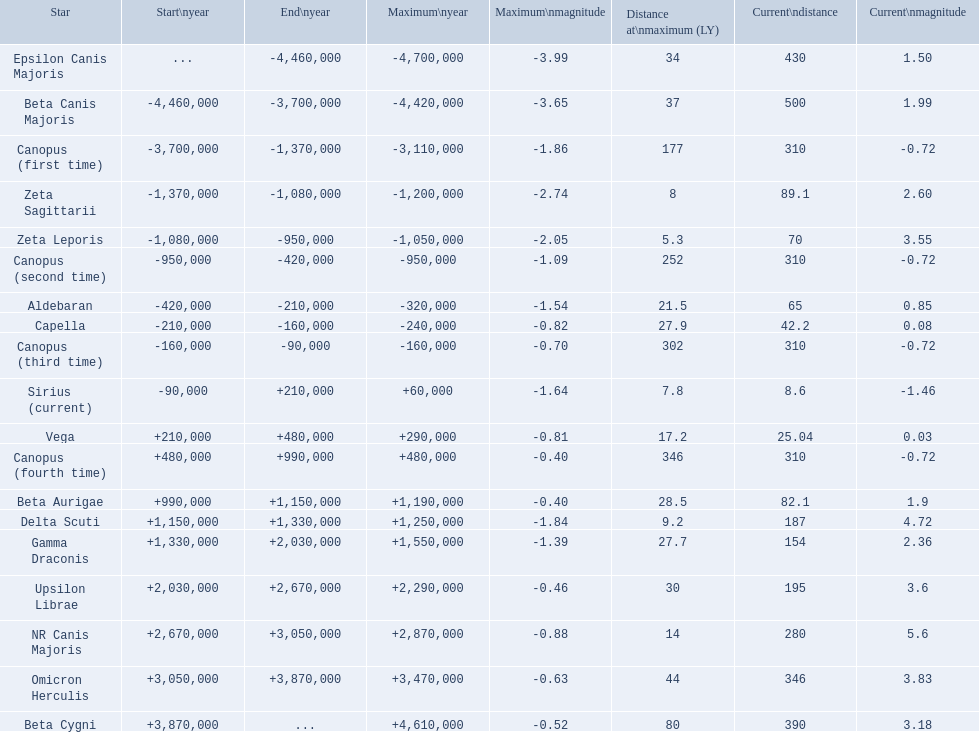What are all the stars? Epsilon Canis Majoris, Beta Canis Majoris, Canopus (first time), Zeta Sagittarii, Zeta Leporis, Canopus (second time), Aldebaran, Capella, Canopus (third time), Sirius (current), Vega, Canopus (fourth time), Beta Aurigae, Delta Scuti, Gamma Draconis, Upsilon Librae, NR Canis Majoris, Omicron Herculis, Beta Cygni. Of those, which star has a maximum distance of 80? Beta Cygni. 